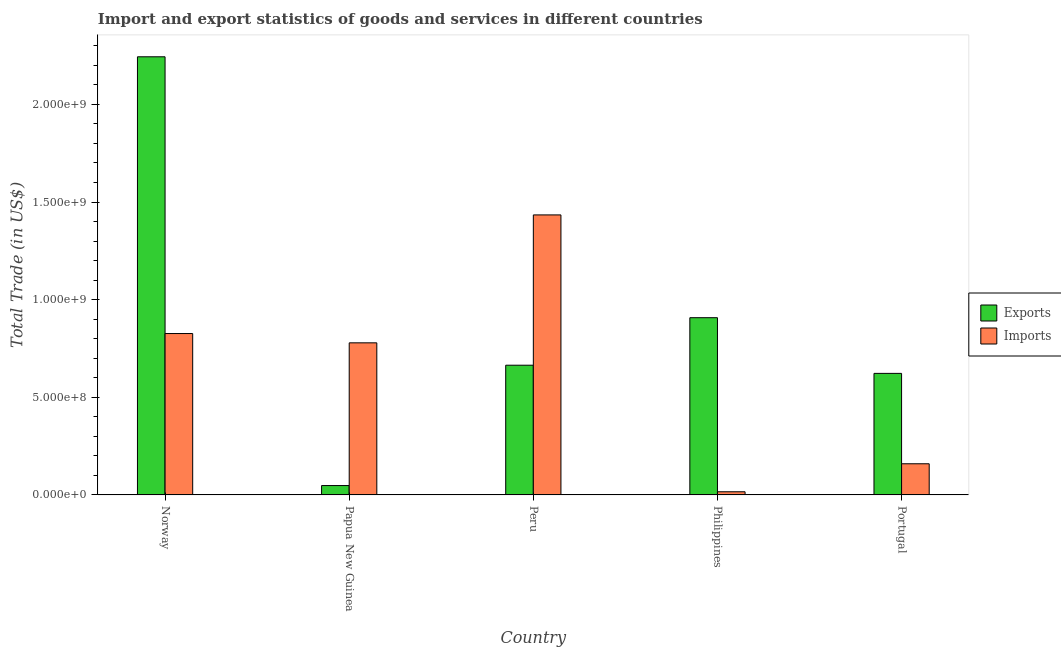How many groups of bars are there?
Your response must be concise. 5. How many bars are there on the 4th tick from the right?
Keep it short and to the point. 2. What is the label of the 2nd group of bars from the left?
Keep it short and to the point. Papua New Guinea. What is the imports of goods and services in Portugal?
Your answer should be very brief. 1.60e+08. Across all countries, what is the maximum imports of goods and services?
Offer a terse response. 1.43e+09. Across all countries, what is the minimum imports of goods and services?
Your answer should be compact. 1.62e+07. In which country was the export of goods and services minimum?
Give a very brief answer. Papua New Guinea. What is the total imports of goods and services in the graph?
Ensure brevity in your answer.  3.22e+09. What is the difference between the imports of goods and services in Peru and that in Philippines?
Give a very brief answer. 1.42e+09. What is the difference between the imports of goods and services in Portugal and the export of goods and services in Peru?
Offer a terse response. -5.05e+08. What is the average imports of goods and services per country?
Make the answer very short. 6.43e+08. What is the difference between the export of goods and services and imports of goods and services in Philippines?
Your response must be concise. 8.91e+08. What is the ratio of the imports of goods and services in Norway to that in Philippines?
Provide a short and direct response. 51.02. Is the export of goods and services in Papua New Guinea less than that in Portugal?
Your answer should be very brief. Yes. Is the difference between the imports of goods and services in Norway and Peru greater than the difference between the export of goods and services in Norway and Peru?
Ensure brevity in your answer.  No. What is the difference between the highest and the second highest export of goods and services?
Make the answer very short. 1.34e+09. What is the difference between the highest and the lowest imports of goods and services?
Your response must be concise. 1.42e+09. Is the sum of the export of goods and services in Papua New Guinea and Philippines greater than the maximum imports of goods and services across all countries?
Your answer should be compact. No. What does the 1st bar from the left in Philippines represents?
Give a very brief answer. Exports. What does the 1st bar from the right in Papua New Guinea represents?
Offer a terse response. Imports. Are all the bars in the graph horizontal?
Your answer should be compact. No. What is the difference between two consecutive major ticks on the Y-axis?
Your answer should be compact. 5.00e+08. How many legend labels are there?
Your response must be concise. 2. How are the legend labels stacked?
Your response must be concise. Vertical. What is the title of the graph?
Give a very brief answer. Import and export statistics of goods and services in different countries. What is the label or title of the Y-axis?
Offer a terse response. Total Trade (in US$). What is the Total Trade (in US$) in Exports in Norway?
Your response must be concise. 2.24e+09. What is the Total Trade (in US$) in Imports in Norway?
Offer a very short reply. 8.27e+08. What is the Total Trade (in US$) of Exports in Papua New Guinea?
Offer a very short reply. 4.80e+07. What is the Total Trade (in US$) of Imports in Papua New Guinea?
Your answer should be compact. 7.79e+08. What is the Total Trade (in US$) of Exports in Peru?
Give a very brief answer. 6.64e+08. What is the Total Trade (in US$) in Imports in Peru?
Your response must be concise. 1.43e+09. What is the Total Trade (in US$) of Exports in Philippines?
Provide a succinct answer. 9.08e+08. What is the Total Trade (in US$) of Imports in Philippines?
Your response must be concise. 1.62e+07. What is the Total Trade (in US$) of Exports in Portugal?
Provide a short and direct response. 6.22e+08. What is the Total Trade (in US$) in Imports in Portugal?
Offer a terse response. 1.60e+08. Across all countries, what is the maximum Total Trade (in US$) in Exports?
Provide a succinct answer. 2.24e+09. Across all countries, what is the maximum Total Trade (in US$) in Imports?
Give a very brief answer. 1.43e+09. Across all countries, what is the minimum Total Trade (in US$) in Exports?
Ensure brevity in your answer.  4.80e+07. Across all countries, what is the minimum Total Trade (in US$) in Imports?
Your answer should be compact. 1.62e+07. What is the total Total Trade (in US$) of Exports in the graph?
Your answer should be very brief. 4.49e+09. What is the total Total Trade (in US$) in Imports in the graph?
Ensure brevity in your answer.  3.22e+09. What is the difference between the Total Trade (in US$) of Exports in Norway and that in Papua New Guinea?
Your answer should be compact. 2.20e+09. What is the difference between the Total Trade (in US$) in Imports in Norway and that in Papua New Guinea?
Your answer should be very brief. 4.76e+07. What is the difference between the Total Trade (in US$) in Exports in Norway and that in Peru?
Make the answer very short. 1.58e+09. What is the difference between the Total Trade (in US$) of Imports in Norway and that in Peru?
Provide a short and direct response. -6.07e+08. What is the difference between the Total Trade (in US$) in Exports in Norway and that in Philippines?
Give a very brief answer. 1.34e+09. What is the difference between the Total Trade (in US$) in Imports in Norway and that in Philippines?
Ensure brevity in your answer.  8.10e+08. What is the difference between the Total Trade (in US$) of Exports in Norway and that in Portugal?
Provide a short and direct response. 1.62e+09. What is the difference between the Total Trade (in US$) of Imports in Norway and that in Portugal?
Provide a short and direct response. 6.67e+08. What is the difference between the Total Trade (in US$) in Exports in Papua New Guinea and that in Peru?
Provide a short and direct response. -6.16e+08. What is the difference between the Total Trade (in US$) of Imports in Papua New Guinea and that in Peru?
Your response must be concise. -6.55e+08. What is the difference between the Total Trade (in US$) of Exports in Papua New Guinea and that in Philippines?
Ensure brevity in your answer.  -8.60e+08. What is the difference between the Total Trade (in US$) of Imports in Papua New Guinea and that in Philippines?
Provide a short and direct response. 7.63e+08. What is the difference between the Total Trade (in US$) in Exports in Papua New Guinea and that in Portugal?
Keep it short and to the point. -5.74e+08. What is the difference between the Total Trade (in US$) of Imports in Papua New Guinea and that in Portugal?
Ensure brevity in your answer.  6.19e+08. What is the difference between the Total Trade (in US$) in Exports in Peru and that in Philippines?
Provide a short and direct response. -2.43e+08. What is the difference between the Total Trade (in US$) of Imports in Peru and that in Philippines?
Your response must be concise. 1.42e+09. What is the difference between the Total Trade (in US$) of Exports in Peru and that in Portugal?
Your answer should be compact. 4.18e+07. What is the difference between the Total Trade (in US$) in Imports in Peru and that in Portugal?
Keep it short and to the point. 1.27e+09. What is the difference between the Total Trade (in US$) in Exports in Philippines and that in Portugal?
Your answer should be compact. 2.85e+08. What is the difference between the Total Trade (in US$) in Imports in Philippines and that in Portugal?
Your answer should be compact. -1.43e+08. What is the difference between the Total Trade (in US$) in Exports in Norway and the Total Trade (in US$) in Imports in Papua New Guinea?
Provide a short and direct response. 1.46e+09. What is the difference between the Total Trade (in US$) in Exports in Norway and the Total Trade (in US$) in Imports in Peru?
Make the answer very short. 8.10e+08. What is the difference between the Total Trade (in US$) in Exports in Norway and the Total Trade (in US$) in Imports in Philippines?
Offer a very short reply. 2.23e+09. What is the difference between the Total Trade (in US$) in Exports in Norway and the Total Trade (in US$) in Imports in Portugal?
Your answer should be very brief. 2.08e+09. What is the difference between the Total Trade (in US$) in Exports in Papua New Guinea and the Total Trade (in US$) in Imports in Peru?
Your response must be concise. -1.39e+09. What is the difference between the Total Trade (in US$) of Exports in Papua New Guinea and the Total Trade (in US$) of Imports in Philippines?
Keep it short and to the point. 3.18e+07. What is the difference between the Total Trade (in US$) in Exports in Papua New Guinea and the Total Trade (in US$) in Imports in Portugal?
Offer a very short reply. -1.12e+08. What is the difference between the Total Trade (in US$) in Exports in Peru and the Total Trade (in US$) in Imports in Philippines?
Make the answer very short. 6.48e+08. What is the difference between the Total Trade (in US$) of Exports in Peru and the Total Trade (in US$) of Imports in Portugal?
Your answer should be compact. 5.05e+08. What is the difference between the Total Trade (in US$) in Exports in Philippines and the Total Trade (in US$) in Imports in Portugal?
Give a very brief answer. 7.48e+08. What is the average Total Trade (in US$) of Exports per country?
Keep it short and to the point. 8.97e+08. What is the average Total Trade (in US$) in Imports per country?
Make the answer very short. 6.43e+08. What is the difference between the Total Trade (in US$) in Exports and Total Trade (in US$) in Imports in Norway?
Keep it short and to the point. 1.42e+09. What is the difference between the Total Trade (in US$) of Exports and Total Trade (in US$) of Imports in Papua New Guinea?
Keep it short and to the point. -7.31e+08. What is the difference between the Total Trade (in US$) of Exports and Total Trade (in US$) of Imports in Peru?
Keep it short and to the point. -7.70e+08. What is the difference between the Total Trade (in US$) of Exports and Total Trade (in US$) of Imports in Philippines?
Your answer should be compact. 8.91e+08. What is the difference between the Total Trade (in US$) in Exports and Total Trade (in US$) in Imports in Portugal?
Offer a very short reply. 4.63e+08. What is the ratio of the Total Trade (in US$) in Exports in Norway to that in Papua New Guinea?
Ensure brevity in your answer.  46.7. What is the ratio of the Total Trade (in US$) of Imports in Norway to that in Papua New Guinea?
Provide a short and direct response. 1.06. What is the ratio of the Total Trade (in US$) in Exports in Norway to that in Peru?
Your answer should be compact. 3.38. What is the ratio of the Total Trade (in US$) of Imports in Norway to that in Peru?
Offer a very short reply. 0.58. What is the ratio of the Total Trade (in US$) of Exports in Norway to that in Philippines?
Offer a very short reply. 2.47. What is the ratio of the Total Trade (in US$) in Imports in Norway to that in Philippines?
Offer a terse response. 51.02. What is the ratio of the Total Trade (in US$) in Exports in Norway to that in Portugal?
Make the answer very short. 3.6. What is the ratio of the Total Trade (in US$) in Imports in Norway to that in Portugal?
Offer a very short reply. 5.18. What is the ratio of the Total Trade (in US$) in Exports in Papua New Guinea to that in Peru?
Your response must be concise. 0.07. What is the ratio of the Total Trade (in US$) in Imports in Papua New Guinea to that in Peru?
Offer a very short reply. 0.54. What is the ratio of the Total Trade (in US$) in Exports in Papua New Guinea to that in Philippines?
Give a very brief answer. 0.05. What is the ratio of the Total Trade (in US$) in Imports in Papua New Guinea to that in Philippines?
Provide a short and direct response. 48.08. What is the ratio of the Total Trade (in US$) in Exports in Papua New Guinea to that in Portugal?
Your response must be concise. 0.08. What is the ratio of the Total Trade (in US$) in Imports in Papua New Guinea to that in Portugal?
Offer a very short reply. 4.88. What is the ratio of the Total Trade (in US$) in Exports in Peru to that in Philippines?
Make the answer very short. 0.73. What is the ratio of the Total Trade (in US$) in Imports in Peru to that in Philippines?
Provide a succinct answer. 88.52. What is the ratio of the Total Trade (in US$) in Exports in Peru to that in Portugal?
Provide a short and direct response. 1.07. What is the ratio of the Total Trade (in US$) in Imports in Peru to that in Portugal?
Make the answer very short. 8.99. What is the ratio of the Total Trade (in US$) in Exports in Philippines to that in Portugal?
Offer a terse response. 1.46. What is the ratio of the Total Trade (in US$) in Imports in Philippines to that in Portugal?
Make the answer very short. 0.1. What is the difference between the highest and the second highest Total Trade (in US$) in Exports?
Offer a very short reply. 1.34e+09. What is the difference between the highest and the second highest Total Trade (in US$) of Imports?
Your response must be concise. 6.07e+08. What is the difference between the highest and the lowest Total Trade (in US$) of Exports?
Make the answer very short. 2.20e+09. What is the difference between the highest and the lowest Total Trade (in US$) of Imports?
Provide a succinct answer. 1.42e+09. 